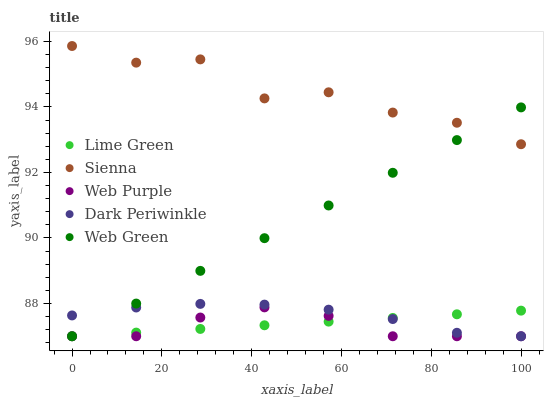Does Web Purple have the minimum area under the curve?
Answer yes or no. Yes. Does Sienna have the maximum area under the curve?
Answer yes or no. Yes. Does Lime Green have the minimum area under the curve?
Answer yes or no. No. Does Lime Green have the maximum area under the curve?
Answer yes or no. No. Is Web Green the smoothest?
Answer yes or no. Yes. Is Sienna the roughest?
Answer yes or no. Yes. Is Web Purple the smoothest?
Answer yes or no. No. Is Web Purple the roughest?
Answer yes or no. No. Does Web Purple have the lowest value?
Answer yes or no. Yes. Does Sienna have the highest value?
Answer yes or no. Yes. Does Web Purple have the highest value?
Answer yes or no. No. Is Web Purple less than Sienna?
Answer yes or no. Yes. Is Sienna greater than Lime Green?
Answer yes or no. Yes. Does Dark Periwinkle intersect Web Green?
Answer yes or no. Yes. Is Dark Periwinkle less than Web Green?
Answer yes or no. No. Is Dark Periwinkle greater than Web Green?
Answer yes or no. No. Does Web Purple intersect Sienna?
Answer yes or no. No. 